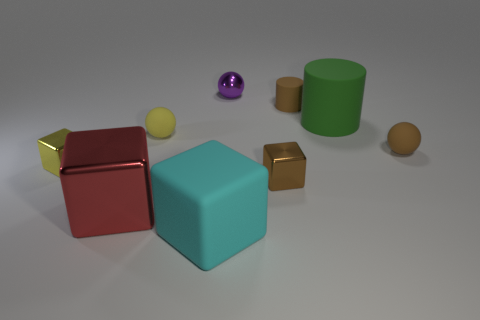Add 1 big yellow rubber cylinders. How many objects exist? 10 Subtract all blocks. How many objects are left? 5 Add 4 small brown objects. How many small brown objects are left? 7 Add 6 small metallic things. How many small metallic things exist? 9 Subtract 1 yellow blocks. How many objects are left? 8 Subtract all big cyan objects. Subtract all large cyan matte blocks. How many objects are left? 7 